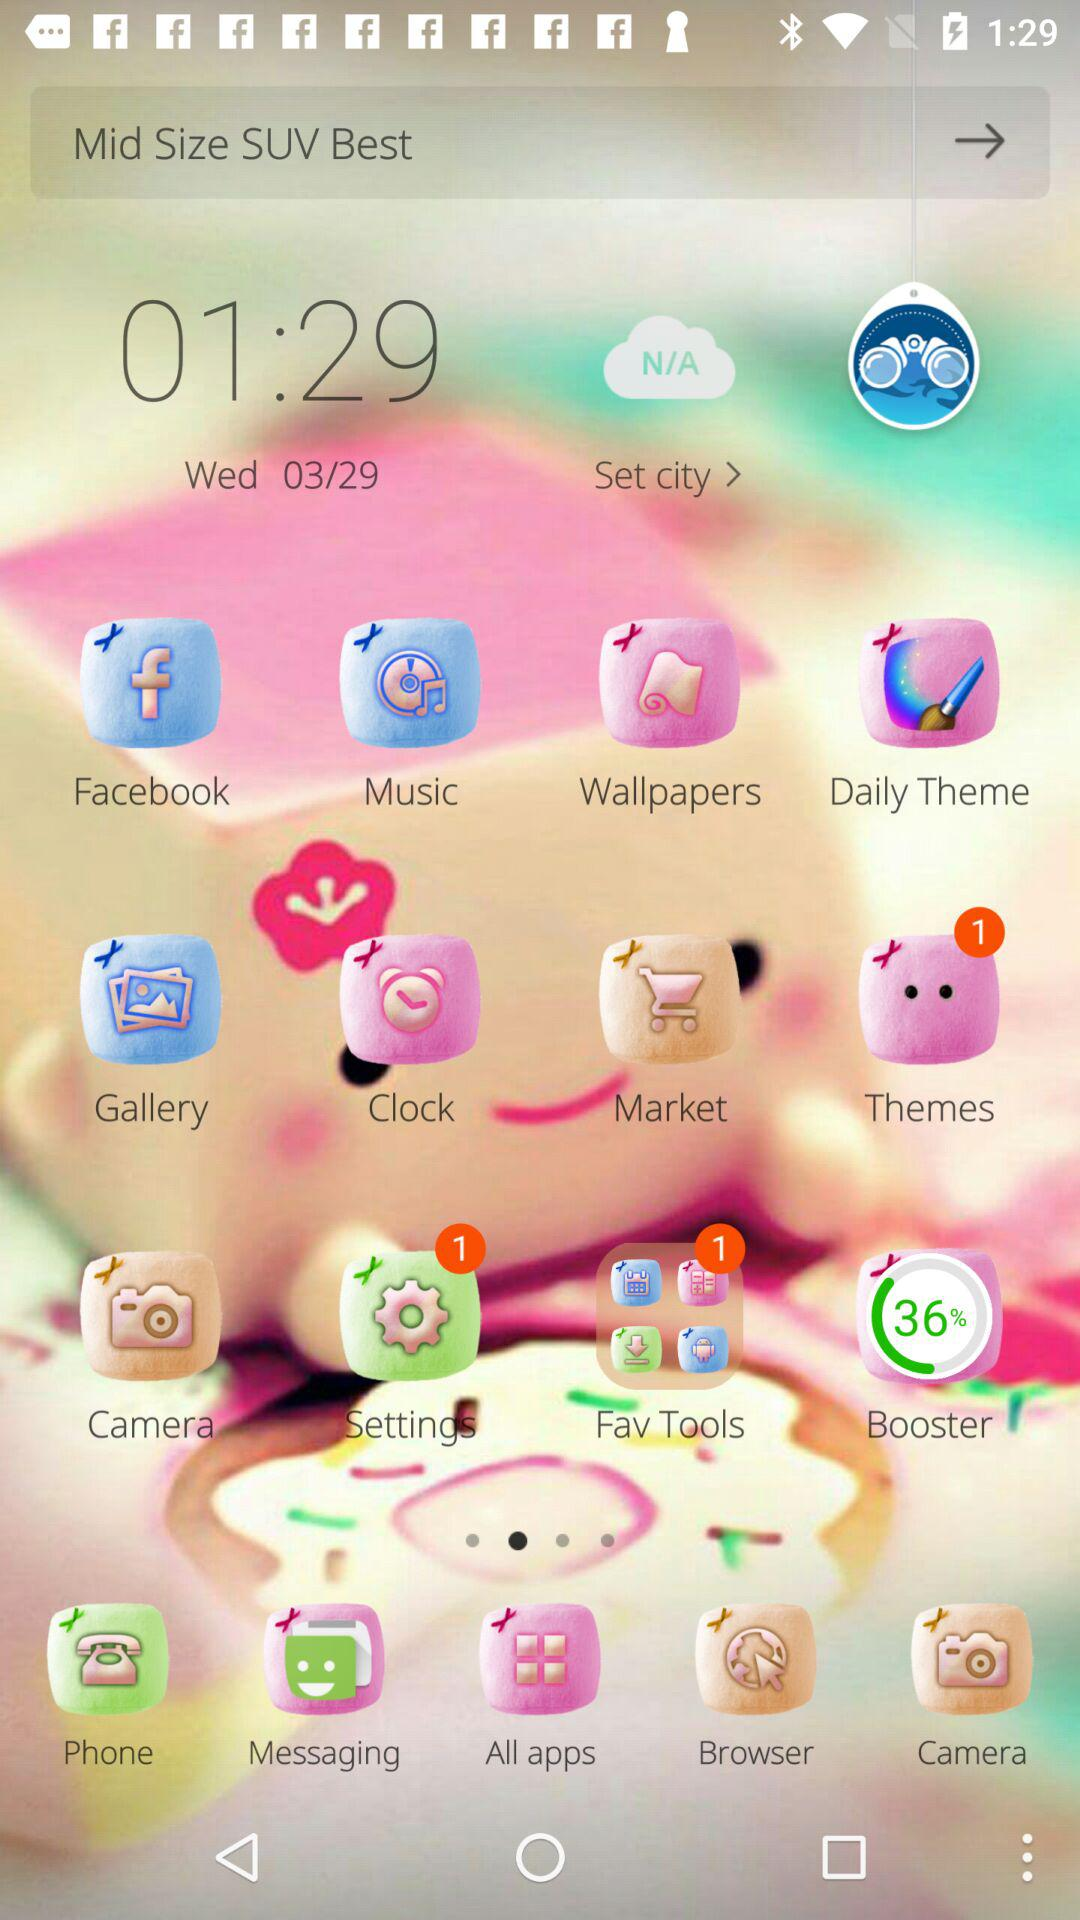What is the given time? The given time is 01:29. 